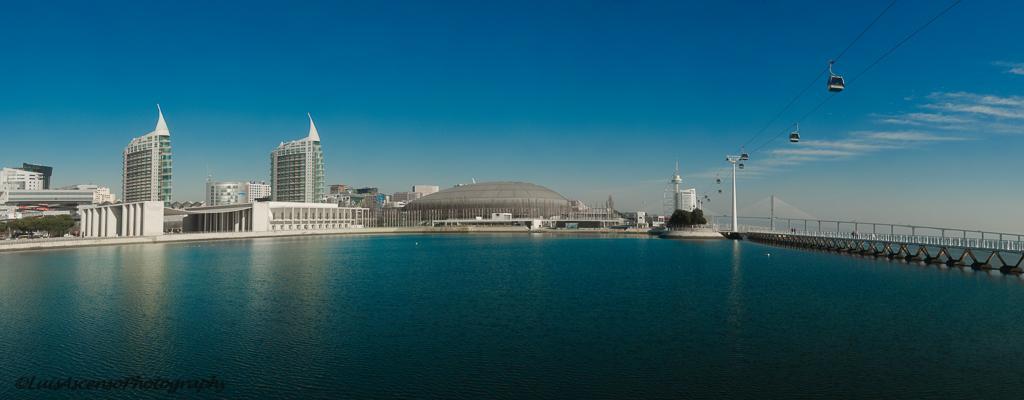Please provide a concise description of this image. In the picture I can see water, bridge, ropeway and in the background of the picture there are some buildings, top of the picture there is clear sky. 